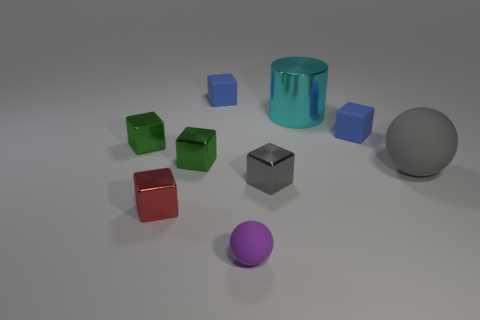Subtract 2 blocks. How many blocks are left? 4 Subtract all small red shiny cubes. How many cubes are left? 5 Subtract all green cubes. How many cubes are left? 4 Subtract all yellow blocks. Subtract all blue balls. How many blocks are left? 6 Add 1 tiny red things. How many objects exist? 10 Subtract all balls. How many objects are left? 7 Add 6 tiny purple things. How many tiny purple things are left? 7 Add 8 purple shiny objects. How many purple shiny objects exist? 8 Subtract 0 brown spheres. How many objects are left? 9 Subtract all gray matte balls. Subtract all blue matte objects. How many objects are left? 6 